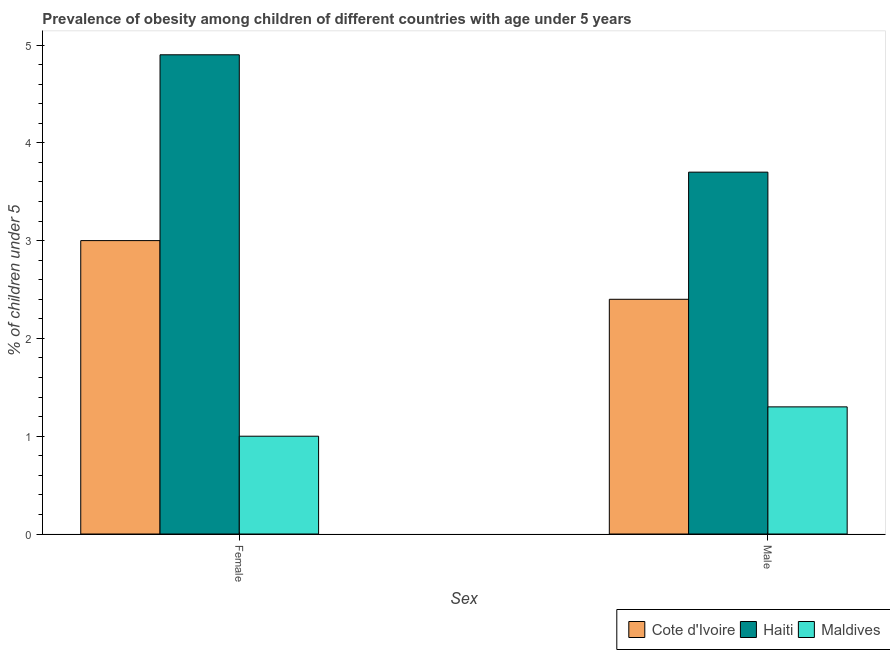Are the number of bars on each tick of the X-axis equal?
Your answer should be compact. Yes. How many bars are there on the 1st tick from the left?
Your answer should be very brief. 3. How many bars are there on the 2nd tick from the right?
Provide a succinct answer. 3. What is the label of the 1st group of bars from the left?
Offer a terse response. Female. What is the percentage of obese female children in Maldives?
Your answer should be compact. 1. Across all countries, what is the maximum percentage of obese male children?
Your answer should be very brief. 3.7. Across all countries, what is the minimum percentage of obese male children?
Your answer should be compact. 1.3. In which country was the percentage of obese female children maximum?
Make the answer very short. Haiti. In which country was the percentage of obese female children minimum?
Make the answer very short. Maldives. What is the total percentage of obese female children in the graph?
Provide a short and direct response. 8.9. What is the difference between the percentage of obese female children in Cote d'Ivoire and that in Maldives?
Provide a succinct answer. 2. What is the difference between the percentage of obese female children in Haiti and the percentage of obese male children in Cote d'Ivoire?
Make the answer very short. 2.5. What is the average percentage of obese male children per country?
Give a very brief answer. 2.47. What is the difference between the percentage of obese male children and percentage of obese female children in Cote d'Ivoire?
Offer a very short reply. -0.6. What is the ratio of the percentage of obese female children in Cote d'Ivoire to that in Maldives?
Your answer should be very brief. 3. What does the 2nd bar from the left in Male represents?
Your answer should be compact. Haiti. What does the 1st bar from the right in Female represents?
Offer a terse response. Maldives. How many countries are there in the graph?
Provide a short and direct response. 3. What is the difference between two consecutive major ticks on the Y-axis?
Offer a terse response. 1. Are the values on the major ticks of Y-axis written in scientific E-notation?
Your answer should be compact. No. Does the graph contain any zero values?
Offer a very short reply. No. Where does the legend appear in the graph?
Keep it short and to the point. Bottom right. How many legend labels are there?
Give a very brief answer. 3. How are the legend labels stacked?
Your answer should be very brief. Horizontal. What is the title of the graph?
Keep it short and to the point. Prevalence of obesity among children of different countries with age under 5 years. Does "Romania" appear as one of the legend labels in the graph?
Offer a very short reply. No. What is the label or title of the X-axis?
Your answer should be very brief. Sex. What is the label or title of the Y-axis?
Your answer should be compact.  % of children under 5. What is the  % of children under 5 of Cote d'Ivoire in Female?
Offer a very short reply. 3. What is the  % of children under 5 in Haiti in Female?
Offer a terse response. 4.9. What is the  % of children under 5 in Cote d'Ivoire in Male?
Your answer should be compact. 2.4. What is the  % of children under 5 in Haiti in Male?
Make the answer very short. 3.7. What is the  % of children under 5 in Maldives in Male?
Keep it short and to the point. 1.3. Across all Sex, what is the maximum  % of children under 5 of Cote d'Ivoire?
Give a very brief answer. 3. Across all Sex, what is the maximum  % of children under 5 of Haiti?
Provide a short and direct response. 4.9. Across all Sex, what is the maximum  % of children under 5 in Maldives?
Provide a succinct answer. 1.3. Across all Sex, what is the minimum  % of children under 5 in Cote d'Ivoire?
Your answer should be compact. 2.4. Across all Sex, what is the minimum  % of children under 5 in Haiti?
Offer a terse response. 3.7. What is the total  % of children under 5 of Cote d'Ivoire in the graph?
Keep it short and to the point. 5.4. What is the total  % of children under 5 of Maldives in the graph?
Provide a succinct answer. 2.3. What is the difference between the  % of children under 5 in Cote d'Ivoire in Female and that in Male?
Your answer should be compact. 0.6. What is the average  % of children under 5 of Haiti per Sex?
Ensure brevity in your answer.  4.3. What is the average  % of children under 5 in Maldives per Sex?
Your answer should be compact. 1.15. What is the difference between the  % of children under 5 in Cote d'Ivoire and  % of children under 5 in Haiti in Female?
Give a very brief answer. -1.9. What is the difference between the  % of children under 5 of Cote d'Ivoire and  % of children under 5 of Maldives in Female?
Your response must be concise. 2. What is the difference between the  % of children under 5 in Haiti and  % of children under 5 in Maldives in Female?
Your answer should be compact. 3.9. What is the difference between the  % of children under 5 of Cote d'Ivoire and  % of children under 5 of Maldives in Male?
Your answer should be compact. 1.1. What is the ratio of the  % of children under 5 of Cote d'Ivoire in Female to that in Male?
Offer a terse response. 1.25. What is the ratio of the  % of children under 5 of Haiti in Female to that in Male?
Make the answer very short. 1.32. What is the ratio of the  % of children under 5 in Maldives in Female to that in Male?
Make the answer very short. 0.77. What is the difference between the highest and the second highest  % of children under 5 in Cote d'Ivoire?
Provide a succinct answer. 0.6. What is the difference between the highest and the second highest  % of children under 5 in Maldives?
Offer a terse response. 0.3. What is the difference between the highest and the lowest  % of children under 5 of Maldives?
Give a very brief answer. 0.3. 